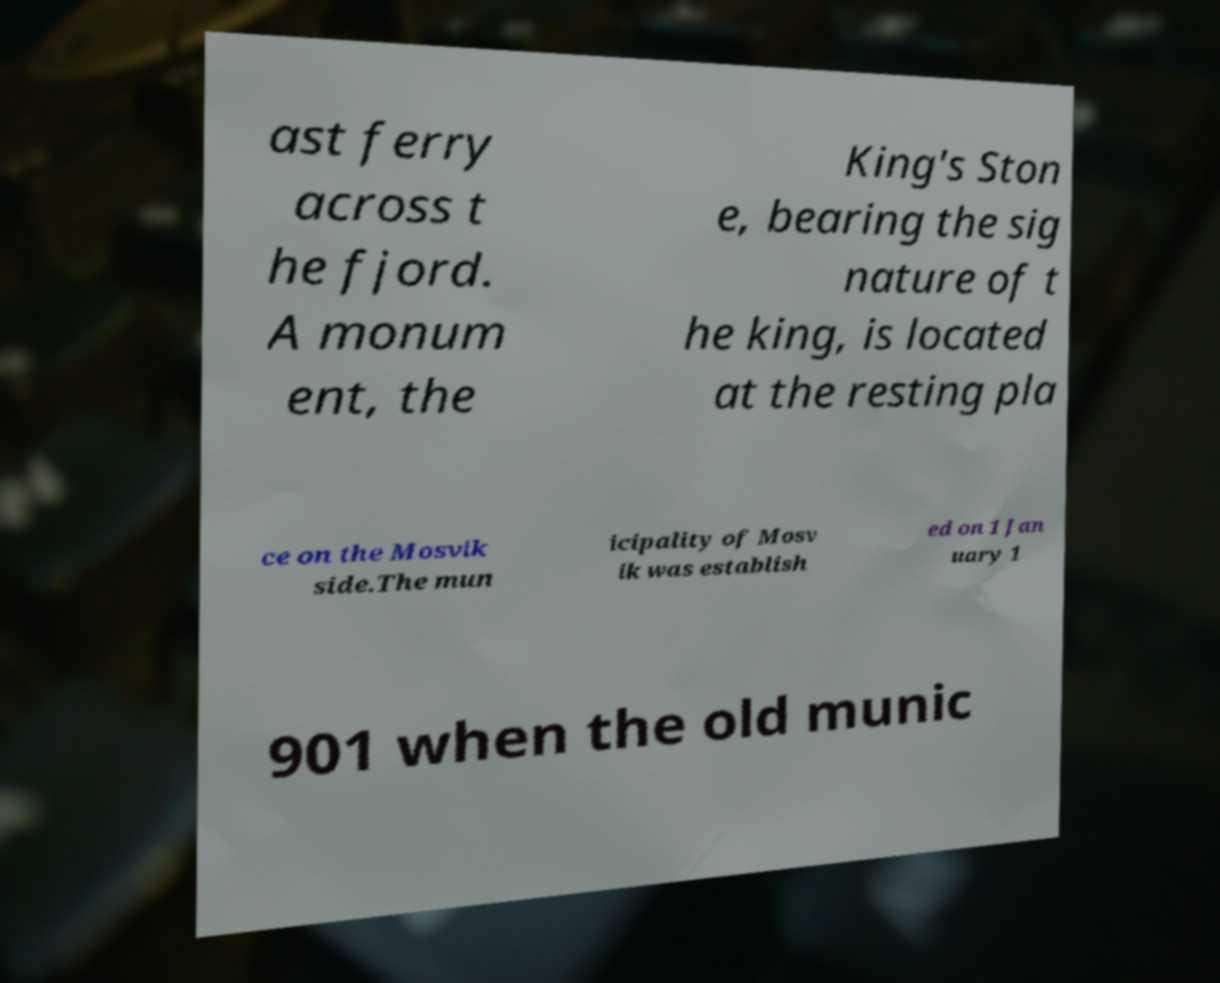For documentation purposes, I need the text within this image transcribed. Could you provide that? ast ferry across t he fjord. A monum ent, the King's Ston e, bearing the sig nature of t he king, is located at the resting pla ce on the Mosvik side.The mun icipality of Mosv ik was establish ed on 1 Jan uary 1 901 when the old munic 